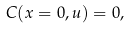Convert formula to latex. <formula><loc_0><loc_0><loc_500><loc_500>C ( x = 0 , u ) = 0 ,</formula> 